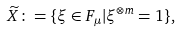Convert formula to latex. <formula><loc_0><loc_0><loc_500><loc_500>\widetilde { X } \colon = \{ \xi \in F _ { \mu } | \xi ^ { \otimes m } = 1 \} ,</formula> 